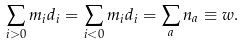<formula> <loc_0><loc_0><loc_500><loc_500>\sum _ { i > 0 } m _ { i } d _ { i } = \sum _ { i < 0 } m _ { i } d _ { i } = \sum _ { a } n _ { a } \equiv w .</formula> 